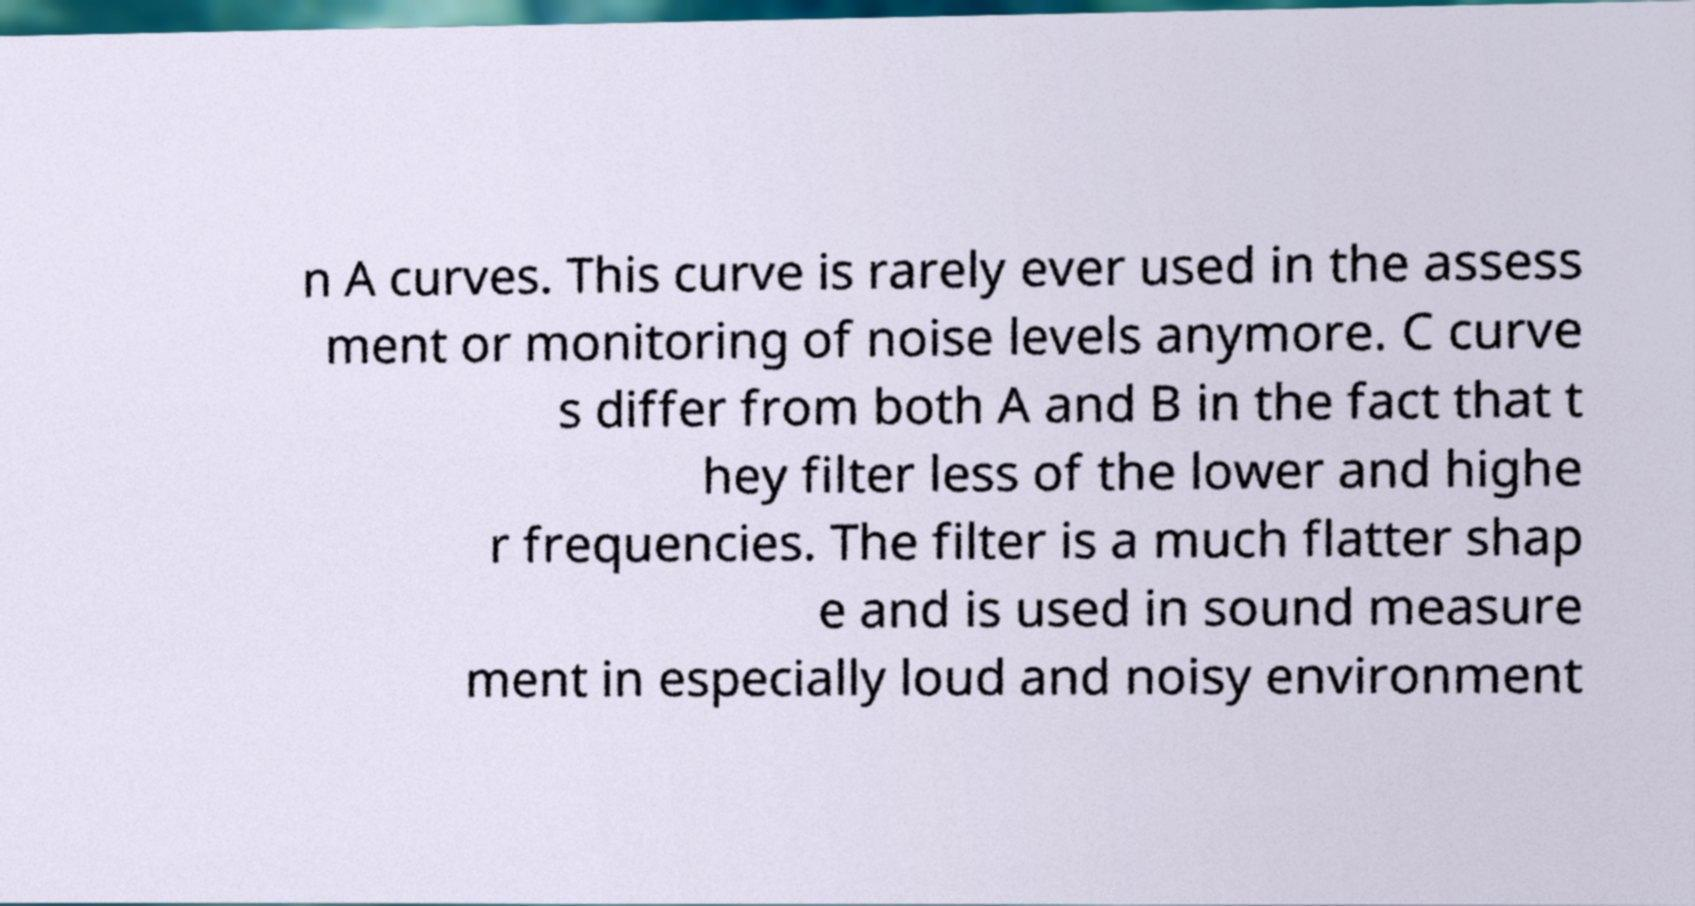For documentation purposes, I need the text within this image transcribed. Could you provide that? n A curves. This curve is rarely ever used in the assess ment or monitoring of noise levels anymore. C curve s differ from both A and B in the fact that t hey filter less of the lower and highe r frequencies. The filter is a much flatter shap e and is used in sound measure ment in especially loud and noisy environment 